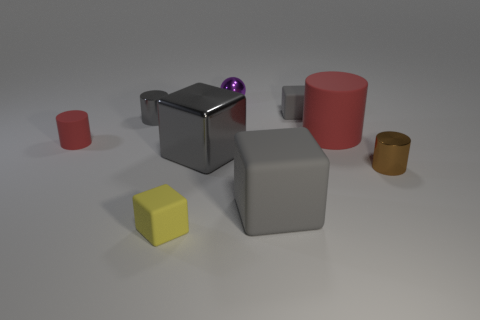What number of things are either yellow matte things or gray matte things behind the small red object?
Provide a short and direct response. 2. What size is the metallic cylinder that is the same color as the large shiny cube?
Your response must be concise. Small. What shape is the tiny brown metallic thing that is in front of the small red rubber object?
Provide a succinct answer. Cylinder. Does the rubber cube that is to the left of the big metal block have the same color as the shiny sphere?
Provide a succinct answer. No. There is a thing that is the same color as the large cylinder; what material is it?
Keep it short and to the point. Rubber. Does the shiny object in front of the metal cube have the same size as the small yellow thing?
Offer a terse response. Yes. Is there a matte cube of the same color as the big metallic block?
Ensure brevity in your answer.  Yes. Is there a red thing on the left side of the tiny gray shiny thing behind the small red cylinder?
Provide a succinct answer. Yes. Is there another cylinder that has the same material as the tiny red cylinder?
Make the answer very short. Yes. The red cylinder left of the gray rubber object that is behind the big gray matte cube is made of what material?
Your answer should be very brief. Rubber. 